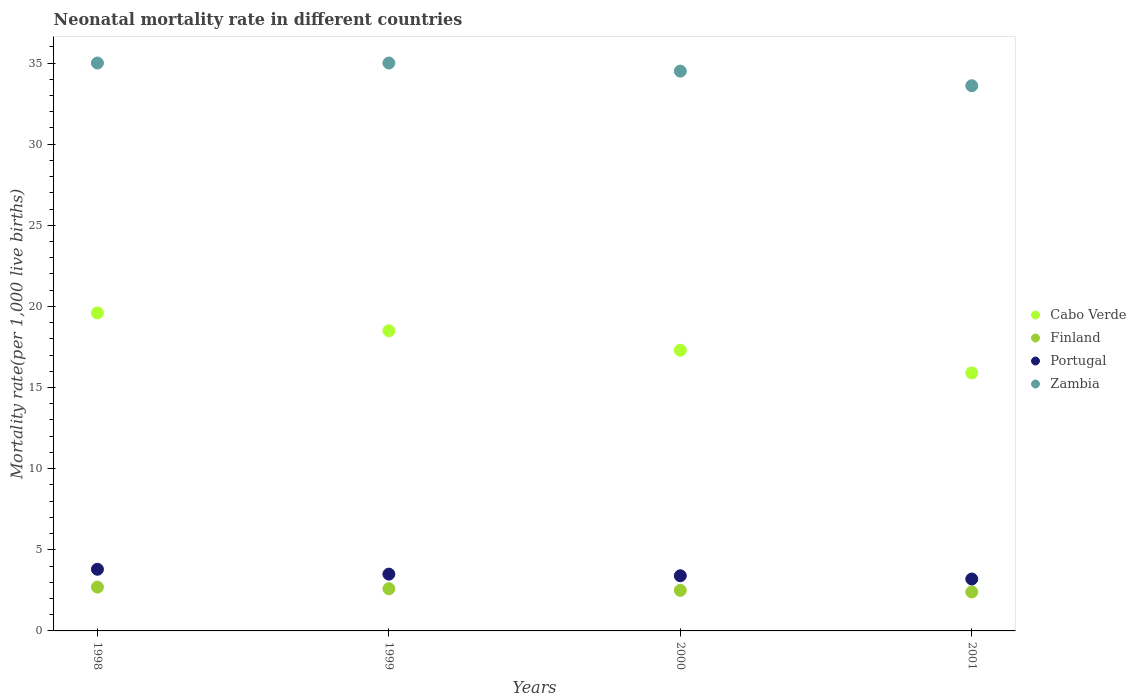How many different coloured dotlines are there?
Offer a terse response. 4. Across all years, what is the maximum neonatal mortality rate in Finland?
Your response must be concise. 2.7. What is the total neonatal mortality rate in Portugal in the graph?
Your response must be concise. 13.9. What is the difference between the neonatal mortality rate in Zambia in 1999 and that in 2001?
Give a very brief answer. 1.4. What is the difference between the neonatal mortality rate in Cabo Verde in 1998 and the neonatal mortality rate in Portugal in 2001?
Provide a succinct answer. 16.4. What is the average neonatal mortality rate in Portugal per year?
Give a very brief answer. 3.47. In the year 1998, what is the difference between the neonatal mortality rate in Portugal and neonatal mortality rate in Zambia?
Keep it short and to the point. -31.2. In how many years, is the neonatal mortality rate in Zambia greater than 26?
Provide a short and direct response. 4. What is the ratio of the neonatal mortality rate in Zambia in 1999 to that in 2001?
Ensure brevity in your answer.  1.04. What is the difference between the highest and the second highest neonatal mortality rate in Cabo Verde?
Offer a very short reply. 1.1. What is the difference between the highest and the lowest neonatal mortality rate in Zambia?
Give a very brief answer. 1.4. Is the sum of the neonatal mortality rate in Portugal in 1998 and 2000 greater than the maximum neonatal mortality rate in Finland across all years?
Offer a terse response. Yes. Does the neonatal mortality rate in Portugal monotonically increase over the years?
Your response must be concise. No. How many years are there in the graph?
Give a very brief answer. 4. Does the graph contain any zero values?
Your response must be concise. No. Does the graph contain grids?
Your answer should be compact. No. How many legend labels are there?
Offer a very short reply. 4. What is the title of the graph?
Your answer should be very brief. Neonatal mortality rate in different countries. Does "Bolivia" appear as one of the legend labels in the graph?
Provide a succinct answer. No. What is the label or title of the X-axis?
Provide a succinct answer. Years. What is the label or title of the Y-axis?
Your response must be concise. Mortality rate(per 1,0 live births). What is the Mortality rate(per 1,000 live births) in Cabo Verde in 1998?
Ensure brevity in your answer.  19.6. What is the Mortality rate(per 1,000 live births) of Finland in 1998?
Offer a very short reply. 2.7. What is the Mortality rate(per 1,000 live births) of Portugal in 1998?
Offer a terse response. 3.8. What is the Mortality rate(per 1,000 live births) in Finland in 1999?
Provide a short and direct response. 2.6. What is the Mortality rate(per 1,000 live births) in Portugal in 1999?
Offer a very short reply. 3.5. What is the Mortality rate(per 1,000 live births) in Portugal in 2000?
Your response must be concise. 3.4. What is the Mortality rate(per 1,000 live births) of Zambia in 2000?
Your answer should be compact. 34.5. What is the Mortality rate(per 1,000 live births) of Finland in 2001?
Give a very brief answer. 2.4. What is the Mortality rate(per 1,000 live births) in Portugal in 2001?
Provide a short and direct response. 3.2. What is the Mortality rate(per 1,000 live births) of Zambia in 2001?
Make the answer very short. 33.6. Across all years, what is the maximum Mortality rate(per 1,000 live births) in Cabo Verde?
Offer a terse response. 19.6. Across all years, what is the maximum Mortality rate(per 1,000 live births) of Portugal?
Offer a terse response. 3.8. Across all years, what is the minimum Mortality rate(per 1,000 live births) of Cabo Verde?
Your answer should be very brief. 15.9. Across all years, what is the minimum Mortality rate(per 1,000 live births) of Finland?
Keep it short and to the point. 2.4. Across all years, what is the minimum Mortality rate(per 1,000 live births) of Portugal?
Provide a succinct answer. 3.2. Across all years, what is the minimum Mortality rate(per 1,000 live births) of Zambia?
Your response must be concise. 33.6. What is the total Mortality rate(per 1,000 live births) in Cabo Verde in the graph?
Offer a very short reply. 71.3. What is the total Mortality rate(per 1,000 live births) of Finland in the graph?
Keep it short and to the point. 10.2. What is the total Mortality rate(per 1,000 live births) of Portugal in the graph?
Your answer should be compact. 13.9. What is the total Mortality rate(per 1,000 live births) of Zambia in the graph?
Offer a terse response. 138.1. What is the difference between the Mortality rate(per 1,000 live births) in Zambia in 1998 and that in 1999?
Offer a terse response. 0. What is the difference between the Mortality rate(per 1,000 live births) of Zambia in 1998 and that in 2000?
Keep it short and to the point. 0.5. What is the difference between the Mortality rate(per 1,000 live births) in Portugal in 1998 and that in 2001?
Give a very brief answer. 0.6. What is the difference between the Mortality rate(per 1,000 live births) in Zambia in 1998 and that in 2001?
Give a very brief answer. 1.4. What is the difference between the Mortality rate(per 1,000 live births) in Cabo Verde in 1999 and that in 2000?
Offer a very short reply. 1.2. What is the difference between the Mortality rate(per 1,000 live births) in Zambia in 1999 and that in 2000?
Keep it short and to the point. 0.5. What is the difference between the Mortality rate(per 1,000 live births) in Finland in 1999 and that in 2001?
Make the answer very short. 0.2. What is the difference between the Mortality rate(per 1,000 live births) of Zambia in 1999 and that in 2001?
Keep it short and to the point. 1.4. What is the difference between the Mortality rate(per 1,000 live births) of Finland in 2000 and that in 2001?
Offer a very short reply. 0.1. What is the difference between the Mortality rate(per 1,000 live births) of Cabo Verde in 1998 and the Mortality rate(per 1,000 live births) of Portugal in 1999?
Provide a succinct answer. 16.1. What is the difference between the Mortality rate(per 1,000 live births) in Cabo Verde in 1998 and the Mortality rate(per 1,000 live births) in Zambia in 1999?
Make the answer very short. -15.4. What is the difference between the Mortality rate(per 1,000 live births) in Finland in 1998 and the Mortality rate(per 1,000 live births) in Zambia in 1999?
Give a very brief answer. -32.3. What is the difference between the Mortality rate(per 1,000 live births) in Portugal in 1998 and the Mortality rate(per 1,000 live births) in Zambia in 1999?
Give a very brief answer. -31.2. What is the difference between the Mortality rate(per 1,000 live births) in Cabo Verde in 1998 and the Mortality rate(per 1,000 live births) in Portugal in 2000?
Provide a short and direct response. 16.2. What is the difference between the Mortality rate(per 1,000 live births) in Cabo Verde in 1998 and the Mortality rate(per 1,000 live births) in Zambia in 2000?
Your answer should be compact. -14.9. What is the difference between the Mortality rate(per 1,000 live births) of Finland in 1998 and the Mortality rate(per 1,000 live births) of Portugal in 2000?
Provide a succinct answer. -0.7. What is the difference between the Mortality rate(per 1,000 live births) in Finland in 1998 and the Mortality rate(per 1,000 live births) in Zambia in 2000?
Offer a terse response. -31.8. What is the difference between the Mortality rate(per 1,000 live births) in Portugal in 1998 and the Mortality rate(per 1,000 live births) in Zambia in 2000?
Your answer should be compact. -30.7. What is the difference between the Mortality rate(per 1,000 live births) in Cabo Verde in 1998 and the Mortality rate(per 1,000 live births) in Zambia in 2001?
Keep it short and to the point. -14. What is the difference between the Mortality rate(per 1,000 live births) in Finland in 1998 and the Mortality rate(per 1,000 live births) in Portugal in 2001?
Ensure brevity in your answer.  -0.5. What is the difference between the Mortality rate(per 1,000 live births) of Finland in 1998 and the Mortality rate(per 1,000 live births) of Zambia in 2001?
Offer a terse response. -30.9. What is the difference between the Mortality rate(per 1,000 live births) of Portugal in 1998 and the Mortality rate(per 1,000 live births) of Zambia in 2001?
Offer a very short reply. -29.8. What is the difference between the Mortality rate(per 1,000 live births) of Cabo Verde in 1999 and the Mortality rate(per 1,000 live births) of Portugal in 2000?
Offer a very short reply. 15.1. What is the difference between the Mortality rate(per 1,000 live births) of Cabo Verde in 1999 and the Mortality rate(per 1,000 live births) of Zambia in 2000?
Make the answer very short. -16. What is the difference between the Mortality rate(per 1,000 live births) in Finland in 1999 and the Mortality rate(per 1,000 live births) in Portugal in 2000?
Your answer should be very brief. -0.8. What is the difference between the Mortality rate(per 1,000 live births) of Finland in 1999 and the Mortality rate(per 1,000 live births) of Zambia in 2000?
Provide a short and direct response. -31.9. What is the difference between the Mortality rate(per 1,000 live births) of Portugal in 1999 and the Mortality rate(per 1,000 live births) of Zambia in 2000?
Give a very brief answer. -31. What is the difference between the Mortality rate(per 1,000 live births) in Cabo Verde in 1999 and the Mortality rate(per 1,000 live births) in Portugal in 2001?
Your answer should be compact. 15.3. What is the difference between the Mortality rate(per 1,000 live births) of Cabo Verde in 1999 and the Mortality rate(per 1,000 live births) of Zambia in 2001?
Offer a terse response. -15.1. What is the difference between the Mortality rate(per 1,000 live births) of Finland in 1999 and the Mortality rate(per 1,000 live births) of Zambia in 2001?
Provide a short and direct response. -31. What is the difference between the Mortality rate(per 1,000 live births) of Portugal in 1999 and the Mortality rate(per 1,000 live births) of Zambia in 2001?
Offer a terse response. -30.1. What is the difference between the Mortality rate(per 1,000 live births) of Cabo Verde in 2000 and the Mortality rate(per 1,000 live births) of Zambia in 2001?
Your response must be concise. -16.3. What is the difference between the Mortality rate(per 1,000 live births) in Finland in 2000 and the Mortality rate(per 1,000 live births) in Zambia in 2001?
Make the answer very short. -31.1. What is the difference between the Mortality rate(per 1,000 live births) of Portugal in 2000 and the Mortality rate(per 1,000 live births) of Zambia in 2001?
Ensure brevity in your answer.  -30.2. What is the average Mortality rate(per 1,000 live births) in Cabo Verde per year?
Keep it short and to the point. 17.82. What is the average Mortality rate(per 1,000 live births) in Finland per year?
Give a very brief answer. 2.55. What is the average Mortality rate(per 1,000 live births) in Portugal per year?
Make the answer very short. 3.48. What is the average Mortality rate(per 1,000 live births) of Zambia per year?
Provide a short and direct response. 34.52. In the year 1998, what is the difference between the Mortality rate(per 1,000 live births) of Cabo Verde and Mortality rate(per 1,000 live births) of Zambia?
Ensure brevity in your answer.  -15.4. In the year 1998, what is the difference between the Mortality rate(per 1,000 live births) in Finland and Mortality rate(per 1,000 live births) in Zambia?
Your answer should be very brief. -32.3. In the year 1998, what is the difference between the Mortality rate(per 1,000 live births) of Portugal and Mortality rate(per 1,000 live births) of Zambia?
Your answer should be very brief. -31.2. In the year 1999, what is the difference between the Mortality rate(per 1,000 live births) of Cabo Verde and Mortality rate(per 1,000 live births) of Finland?
Ensure brevity in your answer.  15.9. In the year 1999, what is the difference between the Mortality rate(per 1,000 live births) of Cabo Verde and Mortality rate(per 1,000 live births) of Portugal?
Ensure brevity in your answer.  15. In the year 1999, what is the difference between the Mortality rate(per 1,000 live births) in Cabo Verde and Mortality rate(per 1,000 live births) in Zambia?
Keep it short and to the point. -16.5. In the year 1999, what is the difference between the Mortality rate(per 1,000 live births) of Finland and Mortality rate(per 1,000 live births) of Portugal?
Provide a short and direct response. -0.9. In the year 1999, what is the difference between the Mortality rate(per 1,000 live births) of Finland and Mortality rate(per 1,000 live births) of Zambia?
Offer a terse response. -32.4. In the year 1999, what is the difference between the Mortality rate(per 1,000 live births) of Portugal and Mortality rate(per 1,000 live births) of Zambia?
Provide a short and direct response. -31.5. In the year 2000, what is the difference between the Mortality rate(per 1,000 live births) of Cabo Verde and Mortality rate(per 1,000 live births) of Finland?
Give a very brief answer. 14.8. In the year 2000, what is the difference between the Mortality rate(per 1,000 live births) of Cabo Verde and Mortality rate(per 1,000 live births) of Zambia?
Provide a succinct answer. -17.2. In the year 2000, what is the difference between the Mortality rate(per 1,000 live births) in Finland and Mortality rate(per 1,000 live births) in Zambia?
Provide a succinct answer. -32. In the year 2000, what is the difference between the Mortality rate(per 1,000 live births) in Portugal and Mortality rate(per 1,000 live births) in Zambia?
Provide a succinct answer. -31.1. In the year 2001, what is the difference between the Mortality rate(per 1,000 live births) of Cabo Verde and Mortality rate(per 1,000 live births) of Finland?
Your answer should be very brief. 13.5. In the year 2001, what is the difference between the Mortality rate(per 1,000 live births) of Cabo Verde and Mortality rate(per 1,000 live births) of Portugal?
Offer a terse response. 12.7. In the year 2001, what is the difference between the Mortality rate(per 1,000 live births) in Cabo Verde and Mortality rate(per 1,000 live births) in Zambia?
Provide a short and direct response. -17.7. In the year 2001, what is the difference between the Mortality rate(per 1,000 live births) of Finland and Mortality rate(per 1,000 live births) of Portugal?
Offer a terse response. -0.8. In the year 2001, what is the difference between the Mortality rate(per 1,000 live births) in Finland and Mortality rate(per 1,000 live births) in Zambia?
Your answer should be very brief. -31.2. In the year 2001, what is the difference between the Mortality rate(per 1,000 live births) of Portugal and Mortality rate(per 1,000 live births) of Zambia?
Your answer should be compact. -30.4. What is the ratio of the Mortality rate(per 1,000 live births) of Cabo Verde in 1998 to that in 1999?
Ensure brevity in your answer.  1.06. What is the ratio of the Mortality rate(per 1,000 live births) of Finland in 1998 to that in 1999?
Ensure brevity in your answer.  1.04. What is the ratio of the Mortality rate(per 1,000 live births) of Portugal in 1998 to that in 1999?
Make the answer very short. 1.09. What is the ratio of the Mortality rate(per 1,000 live births) in Cabo Verde in 1998 to that in 2000?
Offer a very short reply. 1.13. What is the ratio of the Mortality rate(per 1,000 live births) of Finland in 1998 to that in 2000?
Make the answer very short. 1.08. What is the ratio of the Mortality rate(per 1,000 live births) in Portugal in 1998 to that in 2000?
Keep it short and to the point. 1.12. What is the ratio of the Mortality rate(per 1,000 live births) in Zambia in 1998 to that in 2000?
Ensure brevity in your answer.  1.01. What is the ratio of the Mortality rate(per 1,000 live births) of Cabo Verde in 1998 to that in 2001?
Ensure brevity in your answer.  1.23. What is the ratio of the Mortality rate(per 1,000 live births) of Finland in 1998 to that in 2001?
Give a very brief answer. 1.12. What is the ratio of the Mortality rate(per 1,000 live births) of Portugal in 1998 to that in 2001?
Your answer should be compact. 1.19. What is the ratio of the Mortality rate(per 1,000 live births) of Zambia in 1998 to that in 2001?
Your response must be concise. 1.04. What is the ratio of the Mortality rate(per 1,000 live births) in Cabo Verde in 1999 to that in 2000?
Your response must be concise. 1.07. What is the ratio of the Mortality rate(per 1,000 live births) in Finland in 1999 to that in 2000?
Give a very brief answer. 1.04. What is the ratio of the Mortality rate(per 1,000 live births) of Portugal in 1999 to that in 2000?
Provide a succinct answer. 1.03. What is the ratio of the Mortality rate(per 1,000 live births) of Zambia in 1999 to that in 2000?
Give a very brief answer. 1.01. What is the ratio of the Mortality rate(per 1,000 live births) in Cabo Verde in 1999 to that in 2001?
Make the answer very short. 1.16. What is the ratio of the Mortality rate(per 1,000 live births) in Portugal in 1999 to that in 2001?
Ensure brevity in your answer.  1.09. What is the ratio of the Mortality rate(per 1,000 live births) in Zambia in 1999 to that in 2001?
Provide a short and direct response. 1.04. What is the ratio of the Mortality rate(per 1,000 live births) of Cabo Verde in 2000 to that in 2001?
Ensure brevity in your answer.  1.09. What is the ratio of the Mortality rate(per 1,000 live births) of Finland in 2000 to that in 2001?
Provide a short and direct response. 1.04. What is the ratio of the Mortality rate(per 1,000 live births) of Zambia in 2000 to that in 2001?
Make the answer very short. 1.03. What is the difference between the highest and the lowest Mortality rate(per 1,000 live births) in Portugal?
Your answer should be very brief. 0.6. 